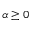<formula> <loc_0><loc_0><loc_500><loc_500>\alpha \geq 0</formula> 